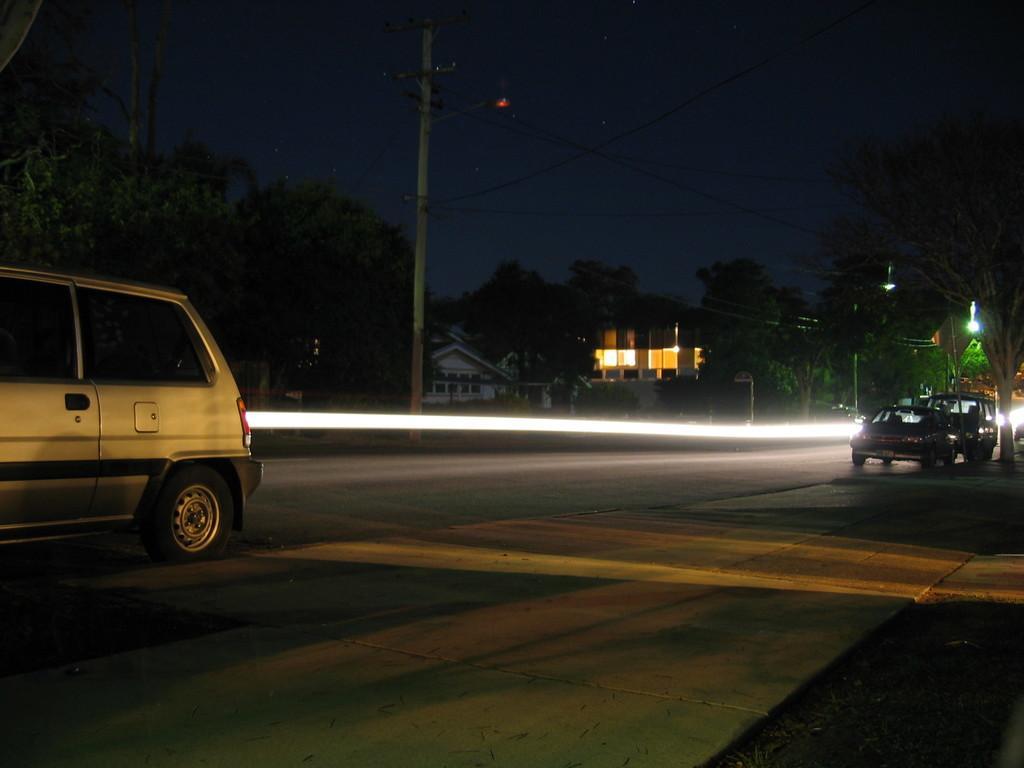Please provide a concise description of this image. This image consists of a road on which we can see the cars. In the background, there are trees and a building. At the top, there is sky. 